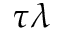Convert formula to latex. <formula><loc_0><loc_0><loc_500><loc_500>\tau \lambda</formula> 